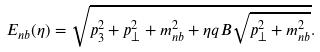Convert formula to latex. <formula><loc_0><loc_0><loc_500><loc_500>E _ { n b } ( \eta ) = \sqrt { p _ { 3 } ^ { 2 } + p _ { \perp } ^ { 2 } + m _ { n b } ^ { 2 } + \eta q B \sqrt { p _ { \perp } ^ { 2 } + m _ { n b } ^ { 2 } } } .</formula> 